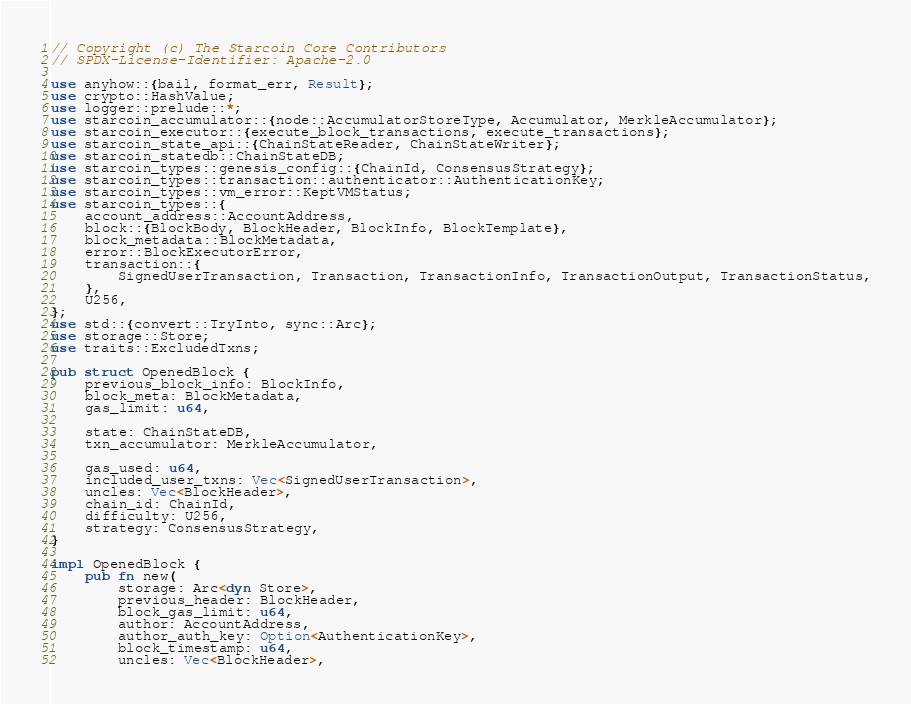Convert code to text. <code><loc_0><loc_0><loc_500><loc_500><_Rust_>// Copyright (c) The Starcoin Core Contributors
// SPDX-License-Identifier: Apache-2.0

use anyhow::{bail, format_err, Result};
use crypto::HashValue;
use logger::prelude::*;
use starcoin_accumulator::{node::AccumulatorStoreType, Accumulator, MerkleAccumulator};
use starcoin_executor::{execute_block_transactions, execute_transactions};
use starcoin_state_api::{ChainStateReader, ChainStateWriter};
use starcoin_statedb::ChainStateDB;
use starcoin_types::genesis_config::{ChainId, ConsensusStrategy};
use starcoin_types::transaction::authenticator::AuthenticationKey;
use starcoin_types::vm_error::KeptVMStatus;
use starcoin_types::{
    account_address::AccountAddress,
    block::{BlockBody, BlockHeader, BlockInfo, BlockTemplate},
    block_metadata::BlockMetadata,
    error::BlockExecutorError,
    transaction::{
        SignedUserTransaction, Transaction, TransactionInfo, TransactionOutput, TransactionStatus,
    },
    U256,
};
use std::{convert::TryInto, sync::Arc};
use storage::Store;
use traits::ExcludedTxns;

pub struct OpenedBlock {
    previous_block_info: BlockInfo,
    block_meta: BlockMetadata,
    gas_limit: u64,

    state: ChainStateDB,
    txn_accumulator: MerkleAccumulator,

    gas_used: u64,
    included_user_txns: Vec<SignedUserTransaction>,
    uncles: Vec<BlockHeader>,
    chain_id: ChainId,
    difficulty: U256,
    strategy: ConsensusStrategy,
}

impl OpenedBlock {
    pub fn new(
        storage: Arc<dyn Store>,
        previous_header: BlockHeader,
        block_gas_limit: u64,
        author: AccountAddress,
        author_auth_key: Option<AuthenticationKey>,
        block_timestamp: u64,
        uncles: Vec<BlockHeader>,</code> 